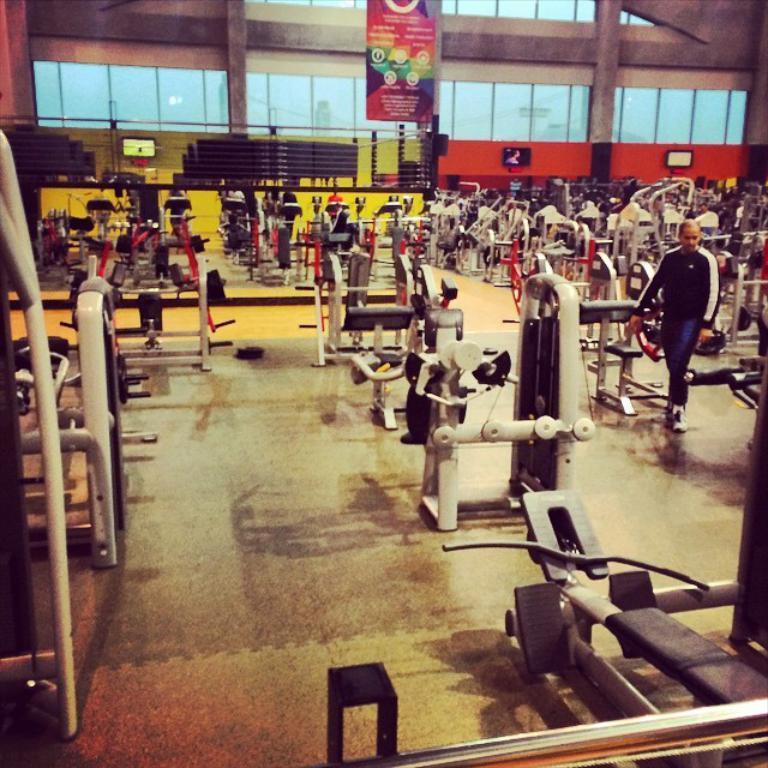Can you describe this image briefly? In this picture we can see gym equipment and a person on the floor and in the background we can see a banner, televisions, wall, glass and some objects. 